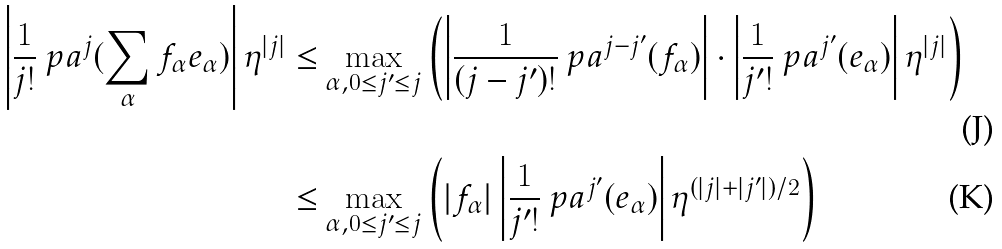Convert formula to latex. <formula><loc_0><loc_0><loc_500><loc_500>\left | \frac { 1 } { j ! } \ p a ^ { j } ( \sum _ { \alpha } f _ { \alpha } e _ { \alpha } ) \right | \eta ^ { | j | } \leq & \max _ { \alpha , 0 \leq j ^ { \prime } \leq j } \left ( \left | \frac { 1 } { ( j - j ^ { \prime } ) ! } \ p a ^ { j - j ^ { \prime } } ( f _ { \alpha } ) \right | \cdot \left | \frac { 1 } { j ^ { \prime } ! } \ p a ^ { j ^ { \prime } } ( e _ { \alpha } ) \right | \eta ^ { | j | } \right ) \\ \leq & \max _ { \alpha , 0 \leq j ^ { \prime } \leq j } \left ( | f _ { \alpha } | \left | \frac { 1 } { j ^ { \prime } ! } \ p a ^ { j ^ { \prime } } ( e _ { \alpha } ) \right | \eta ^ { ( | j | + | j ^ { \prime } | ) / 2 } \right )</formula> 